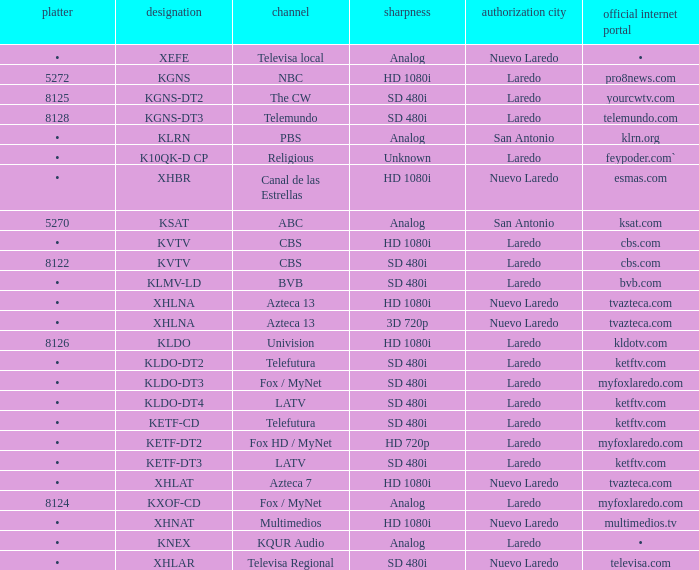Name the resolution for ketftv.com and callsign of kldo-dt2 SD 480i. 